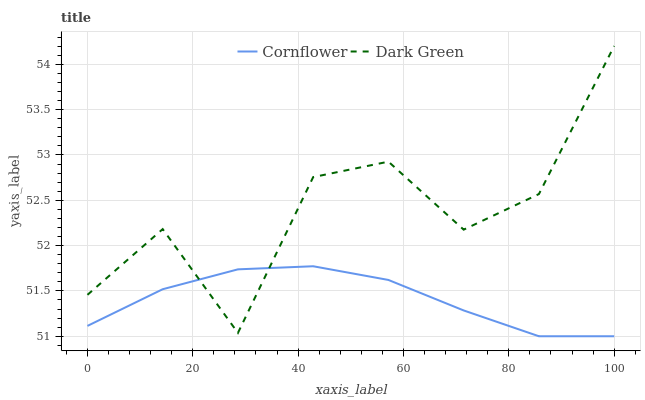Does Cornflower have the minimum area under the curve?
Answer yes or no. Yes. Does Dark Green have the maximum area under the curve?
Answer yes or no. Yes. Does Dark Green have the minimum area under the curve?
Answer yes or no. No. Is Cornflower the smoothest?
Answer yes or no. Yes. Is Dark Green the roughest?
Answer yes or no. Yes. Is Dark Green the smoothest?
Answer yes or no. No. Does Cornflower have the lowest value?
Answer yes or no. Yes. Does Dark Green have the lowest value?
Answer yes or no. No. Does Dark Green have the highest value?
Answer yes or no. Yes. Does Cornflower intersect Dark Green?
Answer yes or no. Yes. Is Cornflower less than Dark Green?
Answer yes or no. No. Is Cornflower greater than Dark Green?
Answer yes or no. No. 